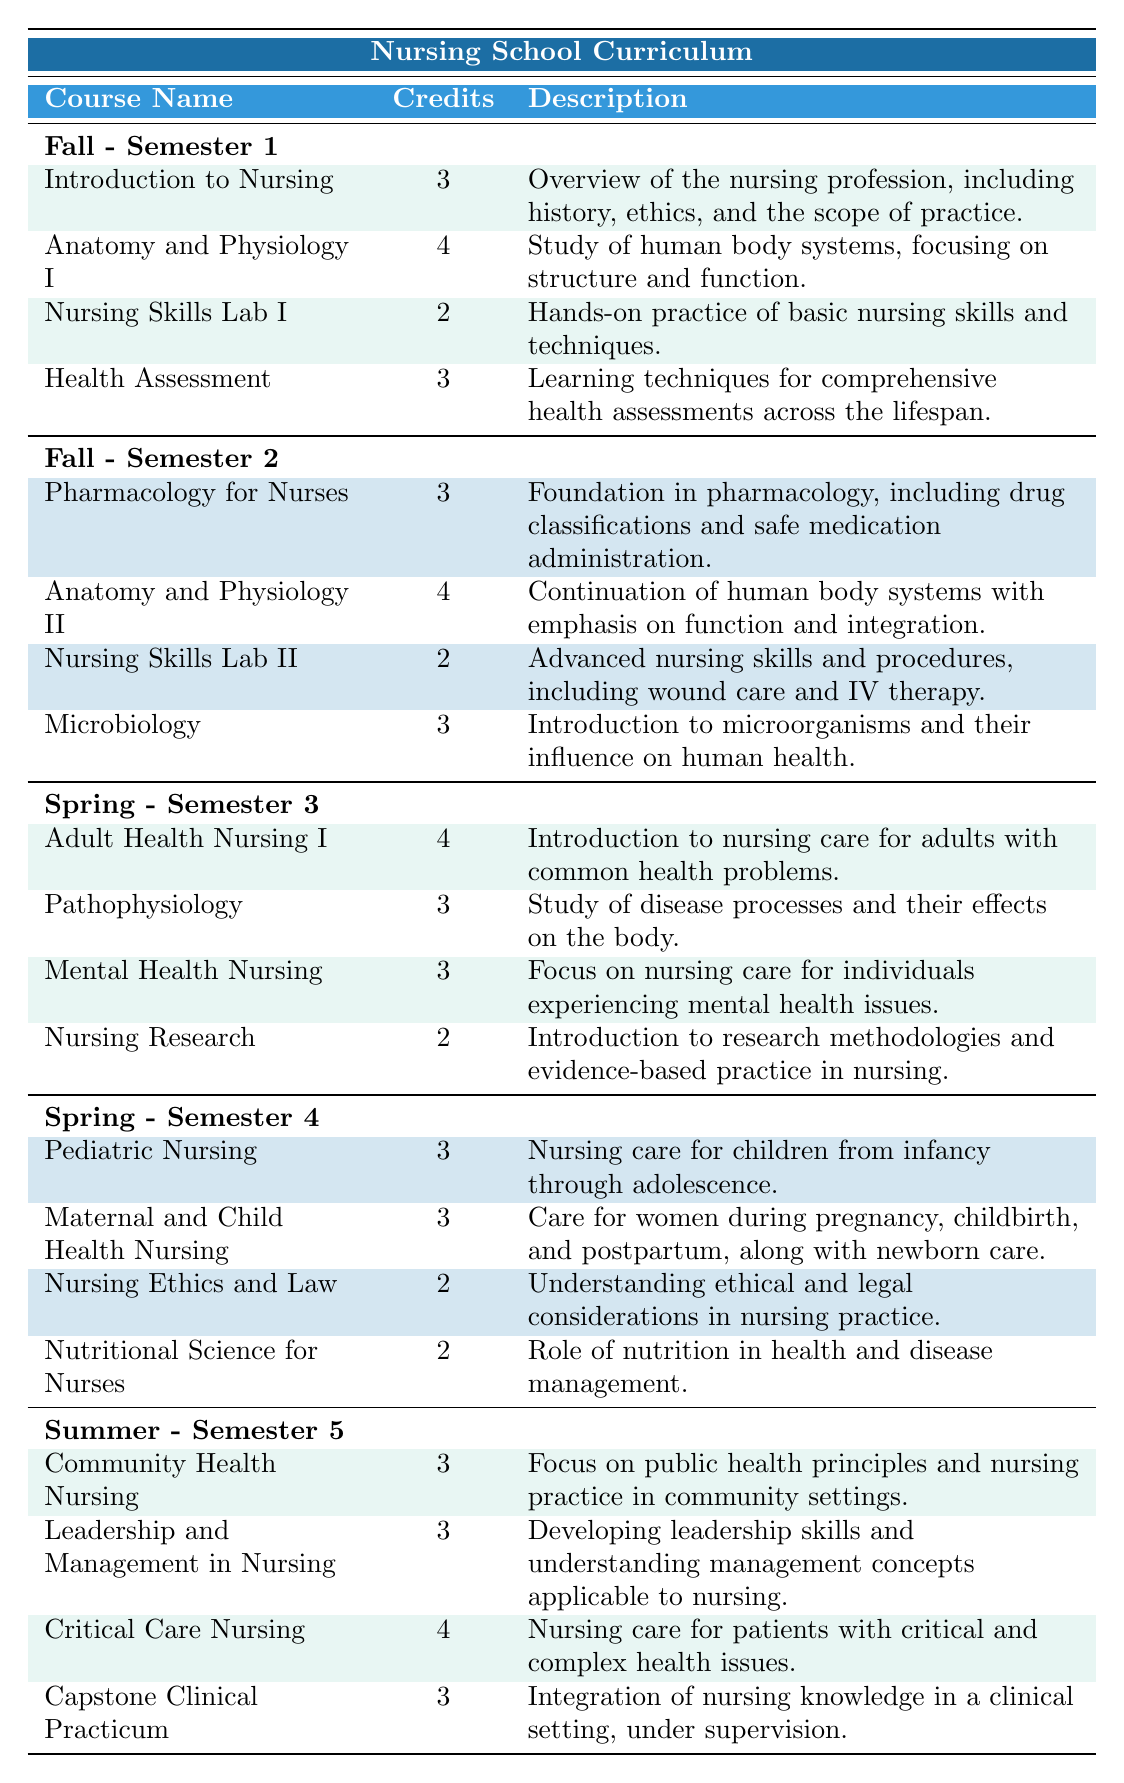What is the total number of credits for Fall Semester 1? The courses in Fall Semester 1 are: Introduction to Nursing (3), Anatomy and Physiology I (4), Nursing Skills Lab I (2), and Health Assessment (3). Adding these together: 3 + 4 + 2 + 3 = 12 credits.
Answer: 12 How many courses are there in Spring Semester 3? There are four courses listed in Spring Semester 3: Adult Health Nursing I, Pathophysiology, Mental Health Nursing, and Nursing Research.
Answer: 4 Is there a course on Leadership and Management in Nursing during the Fall semester? The Leadership and Management in Nursing course is found in Summer Semester 5, not in the Fall semester. Therefore, the answer is no.
Answer: No What is the average number of credits for courses in Spring Semester 4? The courses in Spring Semester 4 are: Pediatric Nursing (3), Maternal and Child Health Nursing (3), Nursing Ethics and Law (2), Nutritional Science for Nurses (2). The total credits = 3 + 3 + 2 + 2 = 10. There are 4 courses, so the average is 10/4 = 2.5.
Answer: 2.5 Which semester has the course "Critical Care Nursing"? "Critical Care Nursing" is listed under Summer Semester 5.
Answer: Summer Semester 5 What course has the highest number of credits in Fall Semester 2? In Fall Semester 2, the course with the highest credits is Anatomy and Physiology II with 4 credits, as the other courses have fewer credits (Pharmacology for Nurses: 3, Nursing Skills Lab II: 2, Microbiology: 3).
Answer: Anatomy and Physiology II How many credits in total are offered across all courses in Semester 5? The courses in Semester 5 are: Community Health Nursing (3), Leadership and Management in Nursing (3), Critical Care Nursing (4), and Capstone Clinical Practicum (3). Their sum is 3 + 3 + 4 + 3 = 13 credits.
Answer: 13 Is Health Assessment a required course in Summer Semester 5? No, Health Assessment is listed in Fall Semester 1, not in Summer Semester 5.
Answer: No What is the total number of courses offered in the Spring semester? The Spring semester consists of 4 courses in Semester 3 and 4 courses in Semester 4, for a total of 4 + 4 = 8 courses in the Spring semester.
Answer: 8 Which course addresses topics related to nutrition? Nutritional Science for Nurses addresses topics related to nutrition, and it is found in Spring Semester 4.
Answer: Nutritional Science for Nurses Count the total number of credits available in the Fall semester. In Fall Semester 1, the total credits are 3 + 4 + 2 + 3 = 12. In Fall Semester 2, they are 3 + 4 + 2 + 3 = 12. Therefore, the total credits in the Fall semester are 12 + 12 = 24.
Answer: 24 